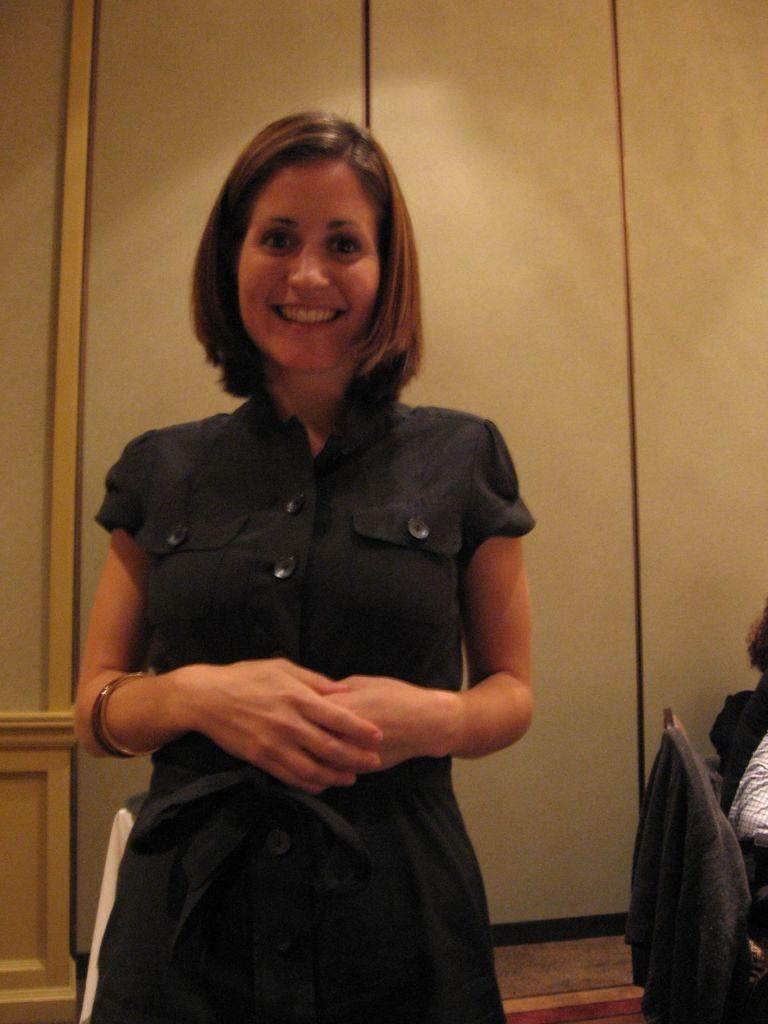What is the primary subject of the image? There is a woman standing in the image. Can you describe the other people in the image? There are people sitting on chairs in the image. How many cakes are being eaten by the ants in the image? There are no cakes or ants present in the image. What is the woman doing with her mouth in the image? The image does not show the woman's mouth or any actions related to it. 